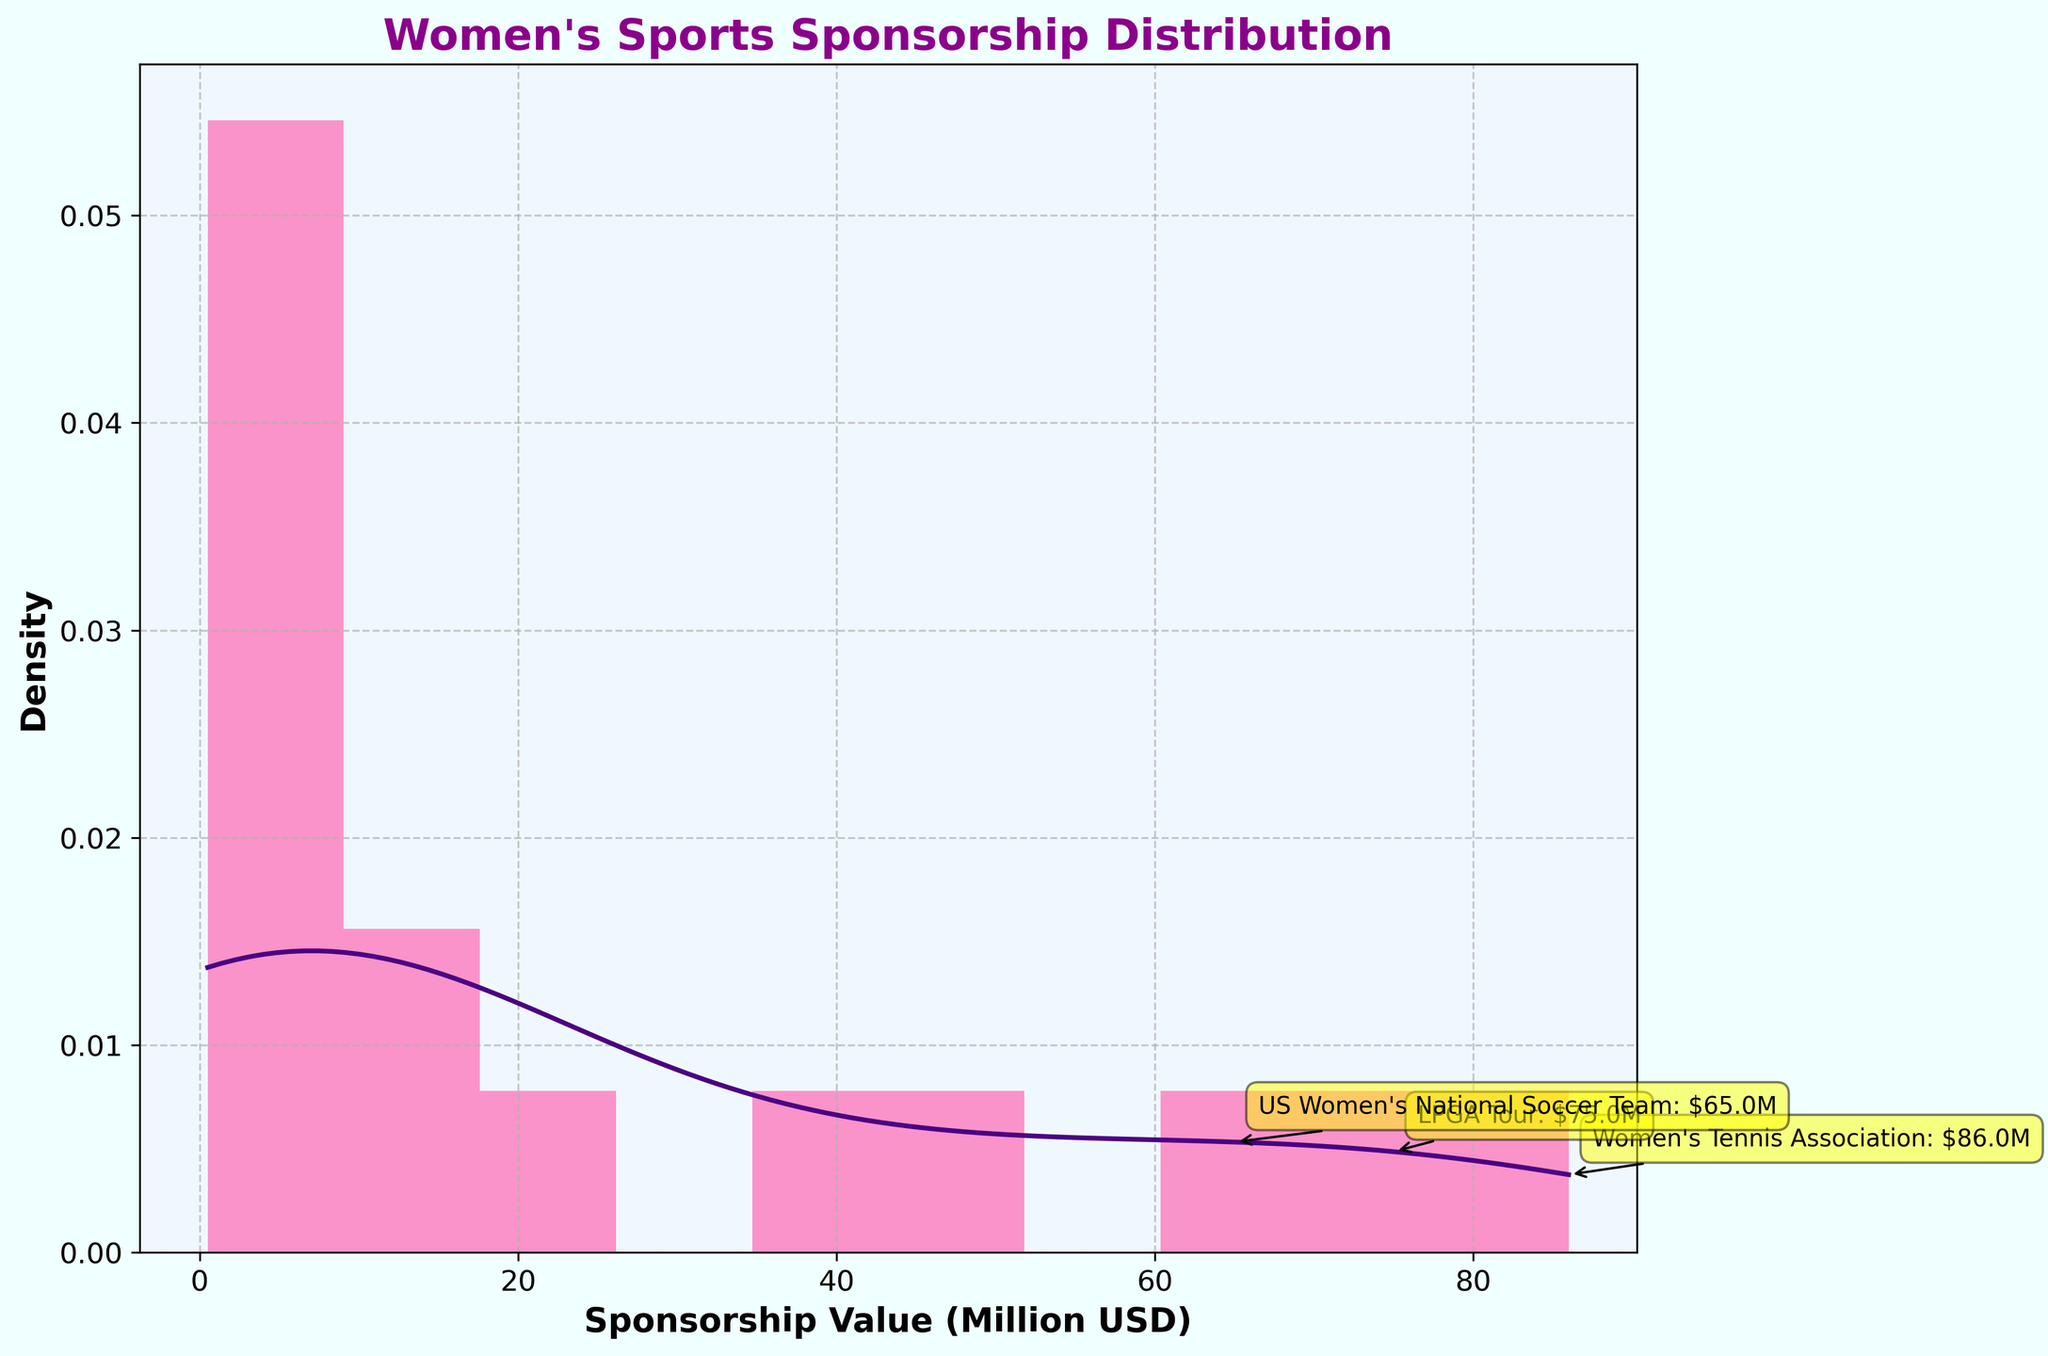what is the title of the plot? The plot’s title is displayed at the top of the plot. Look at the text in a larger font size and bold above the histogram and KDE curve.
Answer: "Women's Sports Sponsorship Distribution" How are the x-axis and y-axis labeled? Read the text labels directly below the x-axis and to the left of the y-axis.
Answer: x-axis: Sponsorship Value (Million USD), y-axis: Density How many data points are represented in the histogram? Count the number of bars in the histogram on the plot. Each bar represents a range of data points. Alternatively, you can sum up all the heights of the bars, since the y-axis label is Density and the area under the histogram equals the number of data points.
Answer: 15 What sponsorship value range has the highest density according to the histogram? Look for the highest bar in the histogram and note the range it covers on the x-axis.
Answer: 50 to 60 million USD Name one of the top sponsors indicated in the plot and their sponsorship value. Refer to the text annotations on the plot for the top sponsors, which are denoted by yellow labels with an arrow.
Answer: Women's Tennis Association: $86.0M Which sponsor has the highest sponsorship value, and how much is it? Look at the top sponsor annotations or the highest x-axis value annotated.
Answer: Women's Tennis Association: $86.0M Compare the sponsorship value of Naomi Osaka and Megan Rapinoe. Who has the higher value and by how much? Find the annotations for both Naomi Osaka and Megan Rapinoe and note their values. Subtract the smaller value from the larger one to determine the difference.
Answer: Naomi Osaka has a higher value by $49.5M (50M - 0.5M) What is the range of sponsorship values covered in the plot? Look at the minimum and maximum x-axis values shown in the histogram. Subtract the minimum value from the maximum value.
Answer: 0.5 million USD to 86 million USD Which density trend does the KDE curve indicate at higher sponsorship values? Observe the shape of the KDE curve towards the higher end of the x-axis (right side). Note whether it is rising, falling, or leveling off.
Answer: Falling curve at higher sponsorship values Identify and explain any gap or outlier visible in the histogram. Look for any significant gaps or unusually high bars within the histogram. This might indicate values that are significantly different from the rest. Note the x-axis range for these gaps/outliers.
Answer: A gap appears between 10M-50M vs 60M-86M. The highest bar on the far right represents outliers 